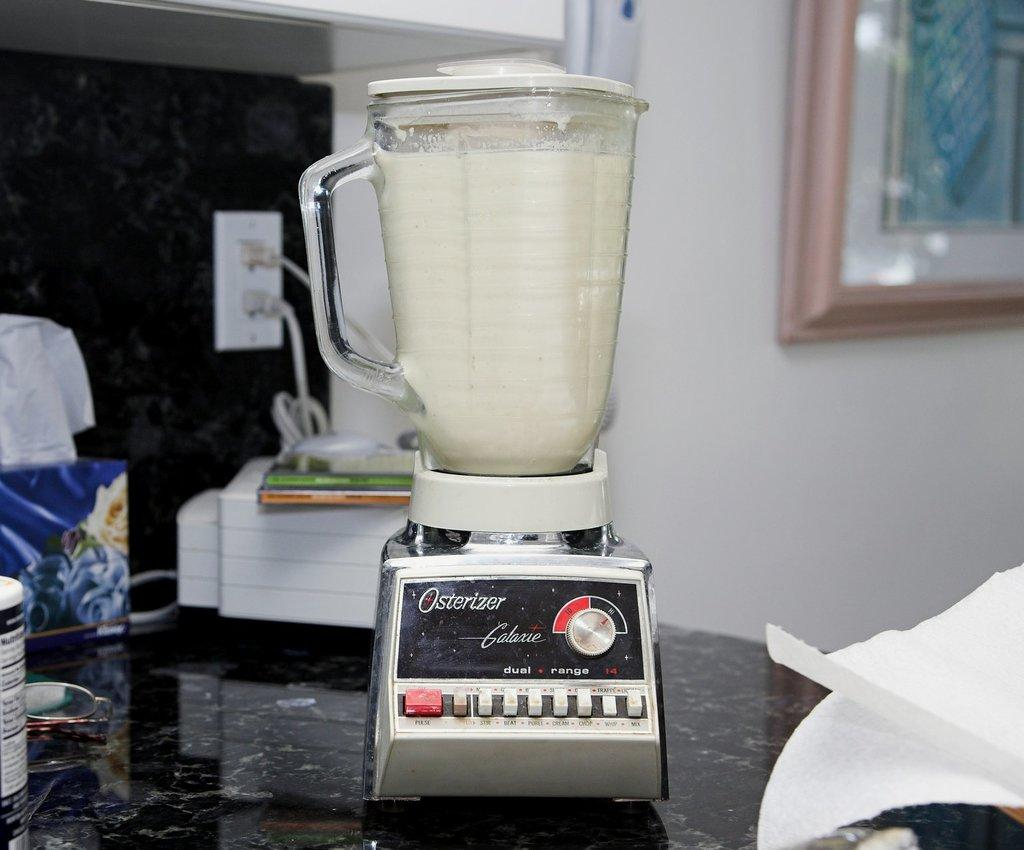<image>
Provide a brief description of the given image. A full Osterizer blender that is on a kitchen counter. 